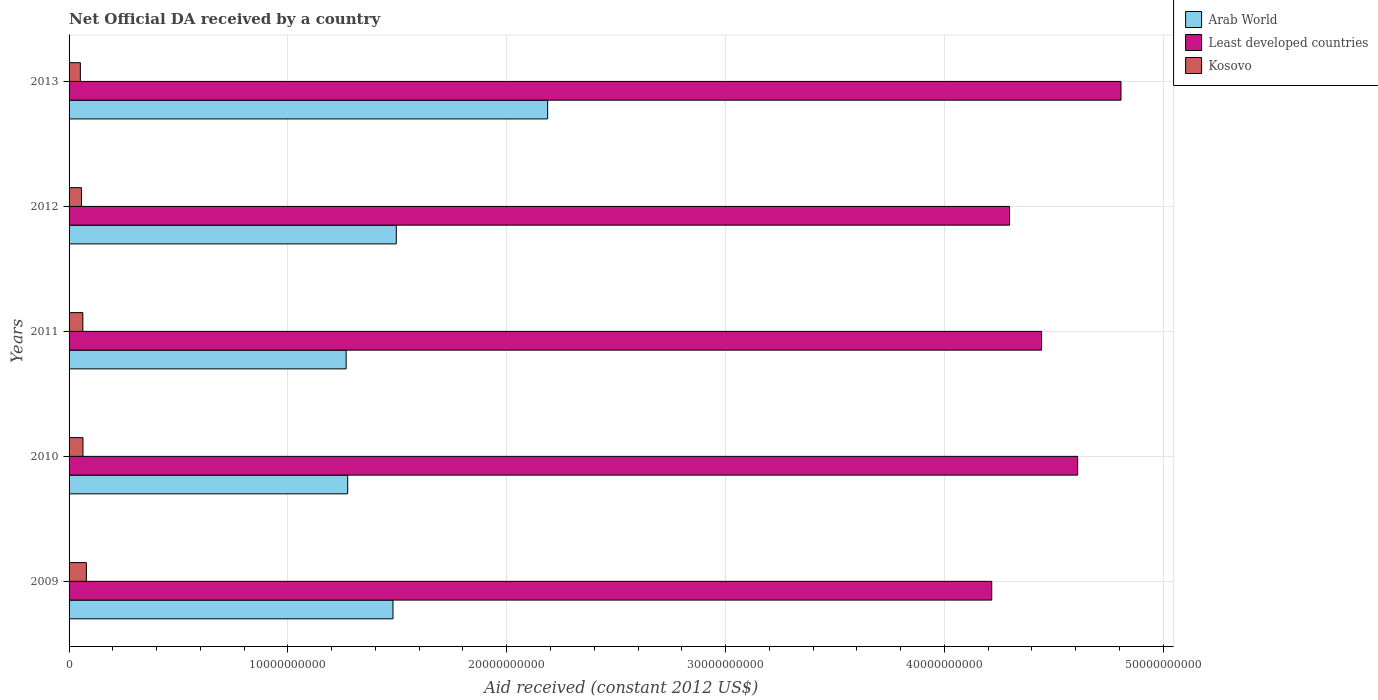How many different coloured bars are there?
Make the answer very short. 3. Are the number of bars per tick equal to the number of legend labels?
Provide a succinct answer. Yes. How many bars are there on the 1st tick from the top?
Keep it short and to the point. 3. How many bars are there on the 1st tick from the bottom?
Offer a very short reply. 3. What is the label of the 2nd group of bars from the top?
Provide a short and direct response. 2012. In how many cases, is the number of bars for a given year not equal to the number of legend labels?
Ensure brevity in your answer.  0. What is the net official development assistance aid received in Least developed countries in 2010?
Your response must be concise. 4.61e+1. Across all years, what is the maximum net official development assistance aid received in Arab World?
Ensure brevity in your answer.  2.19e+1. Across all years, what is the minimum net official development assistance aid received in Kosovo?
Ensure brevity in your answer.  5.16e+08. In which year was the net official development assistance aid received in Kosovo maximum?
Provide a succinct answer. 2009. In which year was the net official development assistance aid received in Arab World minimum?
Offer a terse response. 2011. What is the total net official development assistance aid received in Least developed countries in the graph?
Keep it short and to the point. 2.24e+11. What is the difference between the net official development assistance aid received in Least developed countries in 2009 and that in 2011?
Your answer should be very brief. -2.28e+09. What is the difference between the net official development assistance aid received in Arab World in 2011 and the net official development assistance aid received in Kosovo in 2013?
Provide a short and direct response. 1.21e+1. What is the average net official development assistance aid received in Least developed countries per year?
Your response must be concise. 4.47e+1. In the year 2011, what is the difference between the net official development assistance aid received in Least developed countries and net official development assistance aid received in Kosovo?
Offer a terse response. 4.38e+1. What is the ratio of the net official development assistance aid received in Least developed countries in 2009 to that in 2012?
Offer a terse response. 0.98. Is the net official development assistance aid received in Arab World in 2010 less than that in 2011?
Your response must be concise. No. Is the difference between the net official development assistance aid received in Least developed countries in 2011 and 2012 greater than the difference between the net official development assistance aid received in Kosovo in 2011 and 2012?
Give a very brief answer. Yes. What is the difference between the highest and the second highest net official development assistance aid received in Kosovo?
Your answer should be compact. 1.55e+08. What is the difference between the highest and the lowest net official development assistance aid received in Least developed countries?
Your answer should be very brief. 5.91e+09. In how many years, is the net official development assistance aid received in Kosovo greater than the average net official development assistance aid received in Kosovo taken over all years?
Make the answer very short. 3. What does the 1st bar from the top in 2012 represents?
Your answer should be very brief. Kosovo. What does the 1st bar from the bottom in 2009 represents?
Your answer should be very brief. Arab World. How many years are there in the graph?
Offer a terse response. 5. How many legend labels are there?
Provide a short and direct response. 3. What is the title of the graph?
Give a very brief answer. Net Official DA received by a country. Does "Cambodia" appear as one of the legend labels in the graph?
Keep it short and to the point. No. What is the label or title of the X-axis?
Your response must be concise. Aid received (constant 2012 US$). What is the Aid received (constant 2012 US$) of Arab World in 2009?
Make the answer very short. 1.48e+1. What is the Aid received (constant 2012 US$) in Least developed countries in 2009?
Your response must be concise. 4.22e+1. What is the Aid received (constant 2012 US$) of Kosovo in 2009?
Provide a succinct answer. 7.90e+08. What is the Aid received (constant 2012 US$) of Arab World in 2010?
Provide a succinct answer. 1.27e+1. What is the Aid received (constant 2012 US$) of Least developed countries in 2010?
Make the answer very short. 4.61e+1. What is the Aid received (constant 2012 US$) in Kosovo in 2010?
Keep it short and to the point. 6.35e+08. What is the Aid received (constant 2012 US$) of Arab World in 2011?
Ensure brevity in your answer.  1.27e+1. What is the Aid received (constant 2012 US$) of Least developed countries in 2011?
Offer a terse response. 4.44e+1. What is the Aid received (constant 2012 US$) of Kosovo in 2011?
Ensure brevity in your answer.  6.30e+08. What is the Aid received (constant 2012 US$) in Arab World in 2012?
Your answer should be very brief. 1.50e+1. What is the Aid received (constant 2012 US$) of Least developed countries in 2012?
Ensure brevity in your answer.  4.30e+1. What is the Aid received (constant 2012 US$) in Kosovo in 2012?
Provide a succinct answer. 5.68e+08. What is the Aid received (constant 2012 US$) of Arab World in 2013?
Provide a short and direct response. 2.19e+1. What is the Aid received (constant 2012 US$) in Least developed countries in 2013?
Give a very brief answer. 4.81e+1. What is the Aid received (constant 2012 US$) of Kosovo in 2013?
Make the answer very short. 5.16e+08. Across all years, what is the maximum Aid received (constant 2012 US$) in Arab World?
Give a very brief answer. 2.19e+1. Across all years, what is the maximum Aid received (constant 2012 US$) in Least developed countries?
Provide a succinct answer. 4.81e+1. Across all years, what is the maximum Aid received (constant 2012 US$) in Kosovo?
Your answer should be very brief. 7.90e+08. Across all years, what is the minimum Aid received (constant 2012 US$) in Arab World?
Offer a very short reply. 1.27e+1. Across all years, what is the minimum Aid received (constant 2012 US$) of Least developed countries?
Your answer should be very brief. 4.22e+1. Across all years, what is the minimum Aid received (constant 2012 US$) in Kosovo?
Offer a very short reply. 5.16e+08. What is the total Aid received (constant 2012 US$) of Arab World in the graph?
Your response must be concise. 7.70e+1. What is the total Aid received (constant 2012 US$) of Least developed countries in the graph?
Provide a short and direct response. 2.24e+11. What is the total Aid received (constant 2012 US$) in Kosovo in the graph?
Provide a short and direct response. 3.14e+09. What is the difference between the Aid received (constant 2012 US$) in Arab World in 2009 and that in 2010?
Provide a succinct answer. 2.07e+09. What is the difference between the Aid received (constant 2012 US$) in Least developed countries in 2009 and that in 2010?
Offer a very short reply. -3.92e+09. What is the difference between the Aid received (constant 2012 US$) in Kosovo in 2009 and that in 2010?
Your answer should be compact. 1.55e+08. What is the difference between the Aid received (constant 2012 US$) in Arab World in 2009 and that in 2011?
Offer a very short reply. 2.14e+09. What is the difference between the Aid received (constant 2012 US$) in Least developed countries in 2009 and that in 2011?
Offer a very short reply. -2.28e+09. What is the difference between the Aid received (constant 2012 US$) in Kosovo in 2009 and that in 2011?
Make the answer very short. 1.60e+08. What is the difference between the Aid received (constant 2012 US$) in Arab World in 2009 and that in 2012?
Offer a terse response. -1.52e+08. What is the difference between the Aid received (constant 2012 US$) of Least developed countries in 2009 and that in 2012?
Offer a terse response. -8.15e+08. What is the difference between the Aid received (constant 2012 US$) of Kosovo in 2009 and that in 2012?
Offer a terse response. 2.23e+08. What is the difference between the Aid received (constant 2012 US$) in Arab World in 2009 and that in 2013?
Give a very brief answer. -7.07e+09. What is the difference between the Aid received (constant 2012 US$) in Least developed countries in 2009 and that in 2013?
Give a very brief answer. -5.91e+09. What is the difference between the Aid received (constant 2012 US$) in Kosovo in 2009 and that in 2013?
Offer a terse response. 2.75e+08. What is the difference between the Aid received (constant 2012 US$) in Arab World in 2010 and that in 2011?
Ensure brevity in your answer.  7.18e+07. What is the difference between the Aid received (constant 2012 US$) in Least developed countries in 2010 and that in 2011?
Provide a succinct answer. 1.65e+09. What is the difference between the Aid received (constant 2012 US$) of Kosovo in 2010 and that in 2011?
Ensure brevity in your answer.  5.39e+06. What is the difference between the Aid received (constant 2012 US$) in Arab World in 2010 and that in 2012?
Offer a very short reply. -2.22e+09. What is the difference between the Aid received (constant 2012 US$) of Least developed countries in 2010 and that in 2012?
Offer a very short reply. 3.11e+09. What is the difference between the Aid received (constant 2012 US$) of Kosovo in 2010 and that in 2012?
Ensure brevity in your answer.  6.75e+07. What is the difference between the Aid received (constant 2012 US$) in Arab World in 2010 and that in 2013?
Give a very brief answer. -9.14e+09. What is the difference between the Aid received (constant 2012 US$) of Least developed countries in 2010 and that in 2013?
Keep it short and to the point. -1.98e+09. What is the difference between the Aid received (constant 2012 US$) of Kosovo in 2010 and that in 2013?
Keep it short and to the point. 1.19e+08. What is the difference between the Aid received (constant 2012 US$) in Arab World in 2011 and that in 2012?
Keep it short and to the point. -2.29e+09. What is the difference between the Aid received (constant 2012 US$) of Least developed countries in 2011 and that in 2012?
Offer a terse response. 1.46e+09. What is the difference between the Aid received (constant 2012 US$) in Kosovo in 2011 and that in 2012?
Offer a terse response. 6.21e+07. What is the difference between the Aid received (constant 2012 US$) in Arab World in 2011 and that in 2013?
Provide a succinct answer. -9.21e+09. What is the difference between the Aid received (constant 2012 US$) in Least developed countries in 2011 and that in 2013?
Offer a terse response. -3.63e+09. What is the difference between the Aid received (constant 2012 US$) of Kosovo in 2011 and that in 2013?
Give a very brief answer. 1.14e+08. What is the difference between the Aid received (constant 2012 US$) in Arab World in 2012 and that in 2013?
Your answer should be compact. -6.92e+09. What is the difference between the Aid received (constant 2012 US$) of Least developed countries in 2012 and that in 2013?
Make the answer very short. -5.09e+09. What is the difference between the Aid received (constant 2012 US$) in Kosovo in 2012 and that in 2013?
Your answer should be compact. 5.20e+07. What is the difference between the Aid received (constant 2012 US$) in Arab World in 2009 and the Aid received (constant 2012 US$) in Least developed countries in 2010?
Your answer should be compact. -3.13e+1. What is the difference between the Aid received (constant 2012 US$) in Arab World in 2009 and the Aid received (constant 2012 US$) in Kosovo in 2010?
Give a very brief answer. 1.42e+1. What is the difference between the Aid received (constant 2012 US$) in Least developed countries in 2009 and the Aid received (constant 2012 US$) in Kosovo in 2010?
Ensure brevity in your answer.  4.15e+1. What is the difference between the Aid received (constant 2012 US$) of Arab World in 2009 and the Aid received (constant 2012 US$) of Least developed countries in 2011?
Provide a short and direct response. -2.96e+1. What is the difference between the Aid received (constant 2012 US$) of Arab World in 2009 and the Aid received (constant 2012 US$) of Kosovo in 2011?
Ensure brevity in your answer.  1.42e+1. What is the difference between the Aid received (constant 2012 US$) in Least developed countries in 2009 and the Aid received (constant 2012 US$) in Kosovo in 2011?
Provide a succinct answer. 4.15e+1. What is the difference between the Aid received (constant 2012 US$) of Arab World in 2009 and the Aid received (constant 2012 US$) of Least developed countries in 2012?
Offer a terse response. -2.82e+1. What is the difference between the Aid received (constant 2012 US$) in Arab World in 2009 and the Aid received (constant 2012 US$) in Kosovo in 2012?
Give a very brief answer. 1.42e+1. What is the difference between the Aid received (constant 2012 US$) in Least developed countries in 2009 and the Aid received (constant 2012 US$) in Kosovo in 2012?
Provide a succinct answer. 4.16e+1. What is the difference between the Aid received (constant 2012 US$) in Arab World in 2009 and the Aid received (constant 2012 US$) in Least developed countries in 2013?
Offer a terse response. -3.33e+1. What is the difference between the Aid received (constant 2012 US$) of Arab World in 2009 and the Aid received (constant 2012 US$) of Kosovo in 2013?
Your answer should be very brief. 1.43e+1. What is the difference between the Aid received (constant 2012 US$) in Least developed countries in 2009 and the Aid received (constant 2012 US$) in Kosovo in 2013?
Your answer should be compact. 4.16e+1. What is the difference between the Aid received (constant 2012 US$) in Arab World in 2010 and the Aid received (constant 2012 US$) in Least developed countries in 2011?
Make the answer very short. -3.17e+1. What is the difference between the Aid received (constant 2012 US$) of Arab World in 2010 and the Aid received (constant 2012 US$) of Kosovo in 2011?
Keep it short and to the point. 1.21e+1. What is the difference between the Aid received (constant 2012 US$) of Least developed countries in 2010 and the Aid received (constant 2012 US$) of Kosovo in 2011?
Provide a short and direct response. 4.55e+1. What is the difference between the Aid received (constant 2012 US$) of Arab World in 2010 and the Aid received (constant 2012 US$) of Least developed countries in 2012?
Provide a succinct answer. -3.02e+1. What is the difference between the Aid received (constant 2012 US$) in Arab World in 2010 and the Aid received (constant 2012 US$) in Kosovo in 2012?
Offer a terse response. 1.22e+1. What is the difference between the Aid received (constant 2012 US$) of Least developed countries in 2010 and the Aid received (constant 2012 US$) of Kosovo in 2012?
Your response must be concise. 4.55e+1. What is the difference between the Aid received (constant 2012 US$) in Arab World in 2010 and the Aid received (constant 2012 US$) in Least developed countries in 2013?
Your answer should be very brief. -3.53e+1. What is the difference between the Aid received (constant 2012 US$) in Arab World in 2010 and the Aid received (constant 2012 US$) in Kosovo in 2013?
Provide a short and direct response. 1.22e+1. What is the difference between the Aid received (constant 2012 US$) of Least developed countries in 2010 and the Aid received (constant 2012 US$) of Kosovo in 2013?
Your answer should be compact. 4.56e+1. What is the difference between the Aid received (constant 2012 US$) in Arab World in 2011 and the Aid received (constant 2012 US$) in Least developed countries in 2012?
Your response must be concise. -3.03e+1. What is the difference between the Aid received (constant 2012 US$) of Arab World in 2011 and the Aid received (constant 2012 US$) of Kosovo in 2012?
Your response must be concise. 1.21e+1. What is the difference between the Aid received (constant 2012 US$) of Least developed countries in 2011 and the Aid received (constant 2012 US$) of Kosovo in 2012?
Your answer should be compact. 4.39e+1. What is the difference between the Aid received (constant 2012 US$) of Arab World in 2011 and the Aid received (constant 2012 US$) of Least developed countries in 2013?
Your response must be concise. -3.54e+1. What is the difference between the Aid received (constant 2012 US$) in Arab World in 2011 and the Aid received (constant 2012 US$) in Kosovo in 2013?
Ensure brevity in your answer.  1.21e+1. What is the difference between the Aid received (constant 2012 US$) in Least developed countries in 2011 and the Aid received (constant 2012 US$) in Kosovo in 2013?
Offer a terse response. 4.39e+1. What is the difference between the Aid received (constant 2012 US$) in Arab World in 2012 and the Aid received (constant 2012 US$) in Least developed countries in 2013?
Offer a terse response. -3.31e+1. What is the difference between the Aid received (constant 2012 US$) in Arab World in 2012 and the Aid received (constant 2012 US$) in Kosovo in 2013?
Offer a very short reply. 1.44e+1. What is the difference between the Aid received (constant 2012 US$) in Least developed countries in 2012 and the Aid received (constant 2012 US$) in Kosovo in 2013?
Provide a succinct answer. 4.25e+1. What is the average Aid received (constant 2012 US$) of Arab World per year?
Your response must be concise. 1.54e+1. What is the average Aid received (constant 2012 US$) of Least developed countries per year?
Offer a terse response. 4.47e+1. What is the average Aid received (constant 2012 US$) of Kosovo per year?
Keep it short and to the point. 6.28e+08. In the year 2009, what is the difference between the Aid received (constant 2012 US$) of Arab World and Aid received (constant 2012 US$) of Least developed countries?
Your answer should be compact. -2.74e+1. In the year 2009, what is the difference between the Aid received (constant 2012 US$) in Arab World and Aid received (constant 2012 US$) in Kosovo?
Your response must be concise. 1.40e+1. In the year 2009, what is the difference between the Aid received (constant 2012 US$) in Least developed countries and Aid received (constant 2012 US$) in Kosovo?
Your answer should be compact. 4.14e+1. In the year 2010, what is the difference between the Aid received (constant 2012 US$) in Arab World and Aid received (constant 2012 US$) in Least developed countries?
Your answer should be very brief. -3.34e+1. In the year 2010, what is the difference between the Aid received (constant 2012 US$) of Arab World and Aid received (constant 2012 US$) of Kosovo?
Provide a succinct answer. 1.21e+1. In the year 2010, what is the difference between the Aid received (constant 2012 US$) of Least developed countries and Aid received (constant 2012 US$) of Kosovo?
Provide a succinct answer. 4.55e+1. In the year 2011, what is the difference between the Aid received (constant 2012 US$) in Arab World and Aid received (constant 2012 US$) in Least developed countries?
Ensure brevity in your answer.  -3.18e+1. In the year 2011, what is the difference between the Aid received (constant 2012 US$) in Arab World and Aid received (constant 2012 US$) in Kosovo?
Provide a short and direct response. 1.20e+1. In the year 2011, what is the difference between the Aid received (constant 2012 US$) in Least developed countries and Aid received (constant 2012 US$) in Kosovo?
Make the answer very short. 4.38e+1. In the year 2012, what is the difference between the Aid received (constant 2012 US$) in Arab World and Aid received (constant 2012 US$) in Least developed countries?
Your response must be concise. -2.80e+1. In the year 2012, what is the difference between the Aid received (constant 2012 US$) in Arab World and Aid received (constant 2012 US$) in Kosovo?
Your answer should be very brief. 1.44e+1. In the year 2012, what is the difference between the Aid received (constant 2012 US$) of Least developed countries and Aid received (constant 2012 US$) of Kosovo?
Your response must be concise. 4.24e+1. In the year 2013, what is the difference between the Aid received (constant 2012 US$) of Arab World and Aid received (constant 2012 US$) of Least developed countries?
Your answer should be compact. -2.62e+1. In the year 2013, what is the difference between the Aid received (constant 2012 US$) in Arab World and Aid received (constant 2012 US$) in Kosovo?
Your answer should be very brief. 2.14e+1. In the year 2013, what is the difference between the Aid received (constant 2012 US$) in Least developed countries and Aid received (constant 2012 US$) in Kosovo?
Give a very brief answer. 4.76e+1. What is the ratio of the Aid received (constant 2012 US$) of Arab World in 2009 to that in 2010?
Your response must be concise. 1.16. What is the ratio of the Aid received (constant 2012 US$) in Least developed countries in 2009 to that in 2010?
Your answer should be compact. 0.91. What is the ratio of the Aid received (constant 2012 US$) of Kosovo in 2009 to that in 2010?
Keep it short and to the point. 1.24. What is the ratio of the Aid received (constant 2012 US$) of Arab World in 2009 to that in 2011?
Provide a succinct answer. 1.17. What is the ratio of the Aid received (constant 2012 US$) in Least developed countries in 2009 to that in 2011?
Make the answer very short. 0.95. What is the ratio of the Aid received (constant 2012 US$) in Kosovo in 2009 to that in 2011?
Offer a terse response. 1.25. What is the ratio of the Aid received (constant 2012 US$) of Kosovo in 2009 to that in 2012?
Your answer should be compact. 1.39. What is the ratio of the Aid received (constant 2012 US$) in Arab World in 2009 to that in 2013?
Offer a very short reply. 0.68. What is the ratio of the Aid received (constant 2012 US$) in Least developed countries in 2009 to that in 2013?
Your answer should be very brief. 0.88. What is the ratio of the Aid received (constant 2012 US$) of Kosovo in 2009 to that in 2013?
Provide a succinct answer. 1.53. What is the ratio of the Aid received (constant 2012 US$) of Arab World in 2010 to that in 2011?
Your answer should be compact. 1.01. What is the ratio of the Aid received (constant 2012 US$) in Least developed countries in 2010 to that in 2011?
Provide a short and direct response. 1.04. What is the ratio of the Aid received (constant 2012 US$) in Kosovo in 2010 to that in 2011?
Ensure brevity in your answer.  1.01. What is the ratio of the Aid received (constant 2012 US$) of Arab World in 2010 to that in 2012?
Offer a terse response. 0.85. What is the ratio of the Aid received (constant 2012 US$) of Least developed countries in 2010 to that in 2012?
Offer a terse response. 1.07. What is the ratio of the Aid received (constant 2012 US$) in Kosovo in 2010 to that in 2012?
Ensure brevity in your answer.  1.12. What is the ratio of the Aid received (constant 2012 US$) in Arab World in 2010 to that in 2013?
Provide a succinct answer. 0.58. What is the ratio of the Aid received (constant 2012 US$) in Least developed countries in 2010 to that in 2013?
Offer a very short reply. 0.96. What is the ratio of the Aid received (constant 2012 US$) in Kosovo in 2010 to that in 2013?
Give a very brief answer. 1.23. What is the ratio of the Aid received (constant 2012 US$) of Arab World in 2011 to that in 2012?
Your answer should be compact. 0.85. What is the ratio of the Aid received (constant 2012 US$) of Least developed countries in 2011 to that in 2012?
Ensure brevity in your answer.  1.03. What is the ratio of the Aid received (constant 2012 US$) in Kosovo in 2011 to that in 2012?
Give a very brief answer. 1.11. What is the ratio of the Aid received (constant 2012 US$) of Arab World in 2011 to that in 2013?
Offer a very short reply. 0.58. What is the ratio of the Aid received (constant 2012 US$) of Least developed countries in 2011 to that in 2013?
Your answer should be very brief. 0.92. What is the ratio of the Aid received (constant 2012 US$) in Kosovo in 2011 to that in 2013?
Keep it short and to the point. 1.22. What is the ratio of the Aid received (constant 2012 US$) of Arab World in 2012 to that in 2013?
Make the answer very short. 0.68. What is the ratio of the Aid received (constant 2012 US$) of Least developed countries in 2012 to that in 2013?
Offer a terse response. 0.89. What is the ratio of the Aid received (constant 2012 US$) of Kosovo in 2012 to that in 2013?
Provide a short and direct response. 1.1. What is the difference between the highest and the second highest Aid received (constant 2012 US$) in Arab World?
Your answer should be compact. 6.92e+09. What is the difference between the highest and the second highest Aid received (constant 2012 US$) in Least developed countries?
Provide a short and direct response. 1.98e+09. What is the difference between the highest and the second highest Aid received (constant 2012 US$) in Kosovo?
Give a very brief answer. 1.55e+08. What is the difference between the highest and the lowest Aid received (constant 2012 US$) in Arab World?
Your response must be concise. 9.21e+09. What is the difference between the highest and the lowest Aid received (constant 2012 US$) of Least developed countries?
Provide a succinct answer. 5.91e+09. What is the difference between the highest and the lowest Aid received (constant 2012 US$) in Kosovo?
Your answer should be very brief. 2.75e+08. 